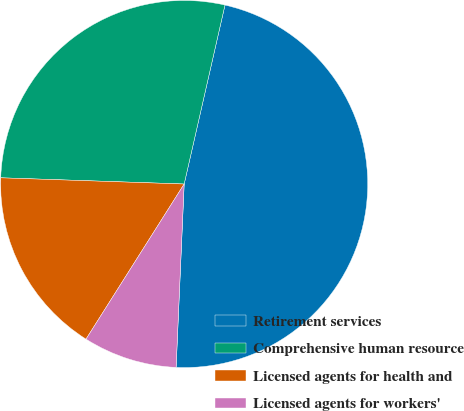Convert chart to OTSL. <chart><loc_0><loc_0><loc_500><loc_500><pie_chart><fcel>Retirement services<fcel>Comprehensive human resource<fcel>Licensed agents for health and<fcel>Licensed agents for workers'<nl><fcel>47.13%<fcel>28.03%<fcel>16.56%<fcel>8.28%<nl></chart> 